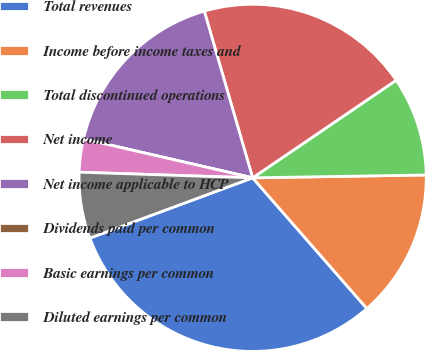Convert chart to OTSL. <chart><loc_0><loc_0><loc_500><loc_500><pie_chart><fcel>Total revenues<fcel>Income before income taxes and<fcel>Total discontinued operations<fcel>Net income<fcel>Net income applicable to HCP<fcel>Dividends paid per common<fcel>Basic earnings per common<fcel>Diluted earnings per common<nl><fcel>30.79%<fcel>13.83%<fcel>9.24%<fcel>19.99%<fcel>16.91%<fcel>0.0%<fcel>3.08%<fcel>6.16%<nl></chart> 